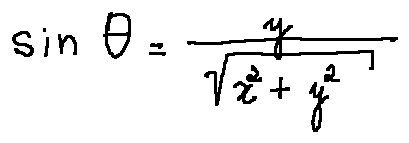Convert formula to latex. <formula><loc_0><loc_0><loc_500><loc_500>\sin \theta = \frac { y } { \sqrt { x ^ { 2 } + y ^ { 2 } } }</formula> 